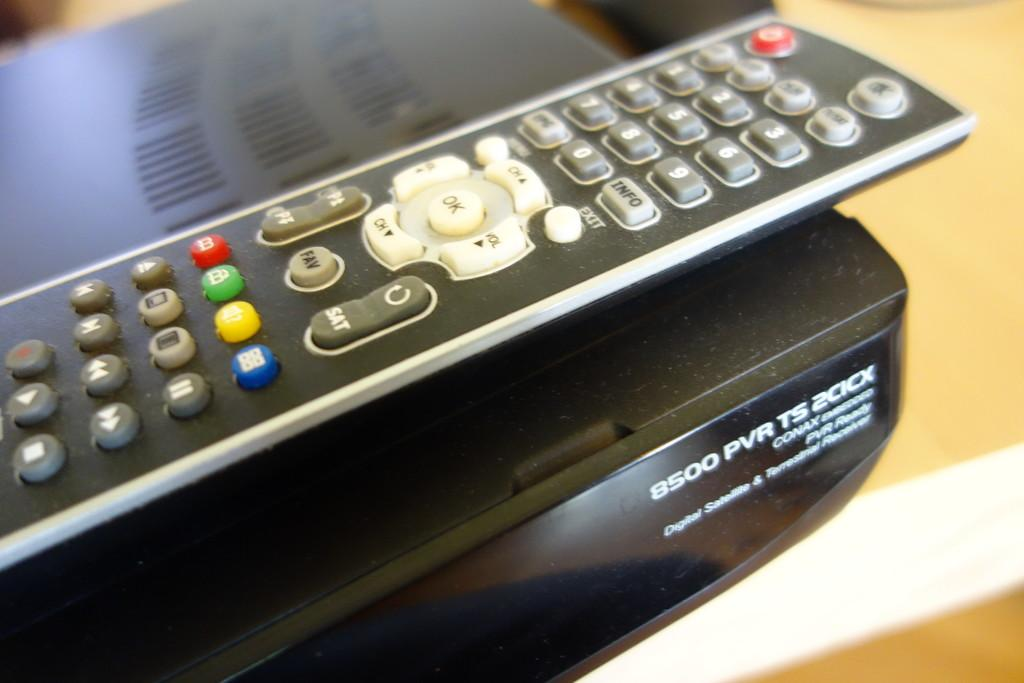Provide a one-sentence caption for the provided image. remote control for the tv and pvr on the bottom. 